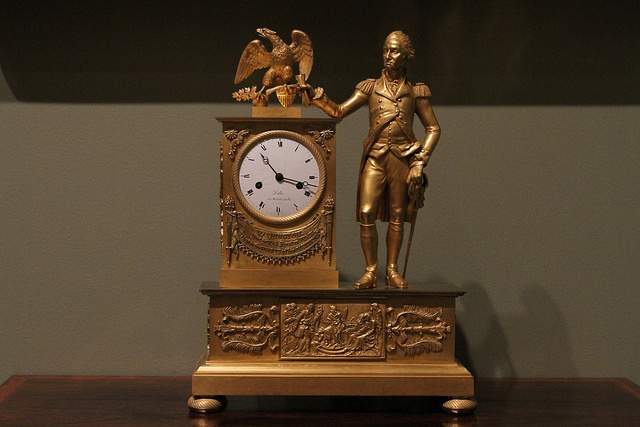Describe the objects in this image and their specific colors. I can see a clock in black, darkgray, and gray tones in this image. 